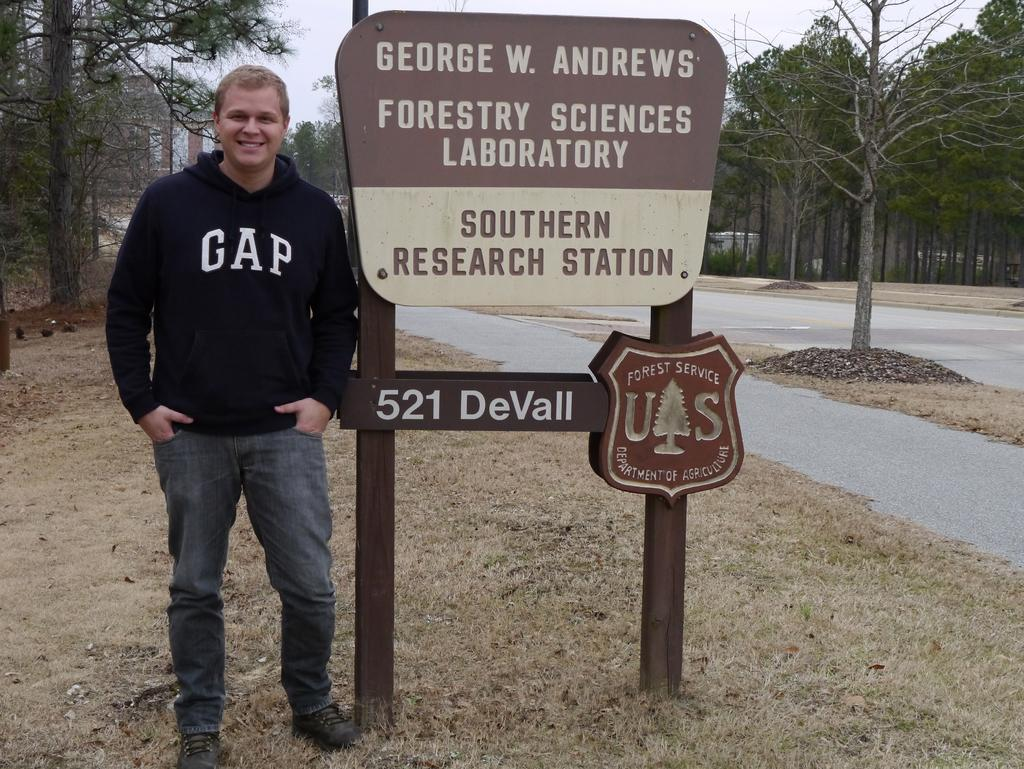What is the main object in the center of the image? There is a name board in the center of the image. Where is the name board located? The name board is on the grass. Can you describe the person on the left side of the name board? There is a person on the left side of the name board, but their appearance or actions are not specified. What can be seen in the background of the image? There are trees, a road, a building, and the sky visible in the background of the image. What time of day is indicated by the hour on the name board? There is no hour or time of day mentioned on the name board in the image. 